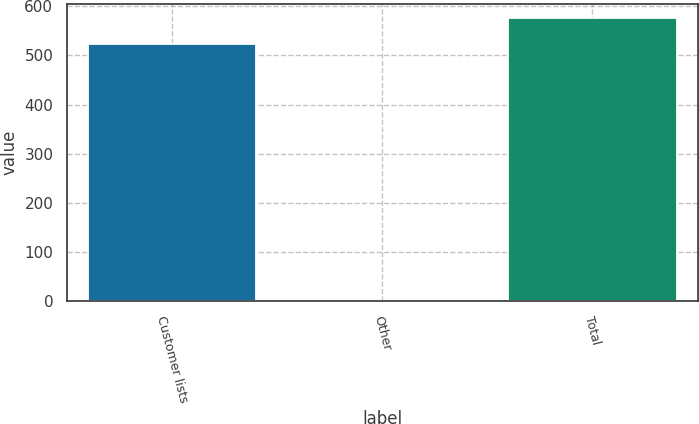<chart> <loc_0><loc_0><loc_500><loc_500><bar_chart><fcel>Customer lists<fcel>Other<fcel>Total<nl><fcel>524<fcel>1<fcel>576.4<nl></chart> 